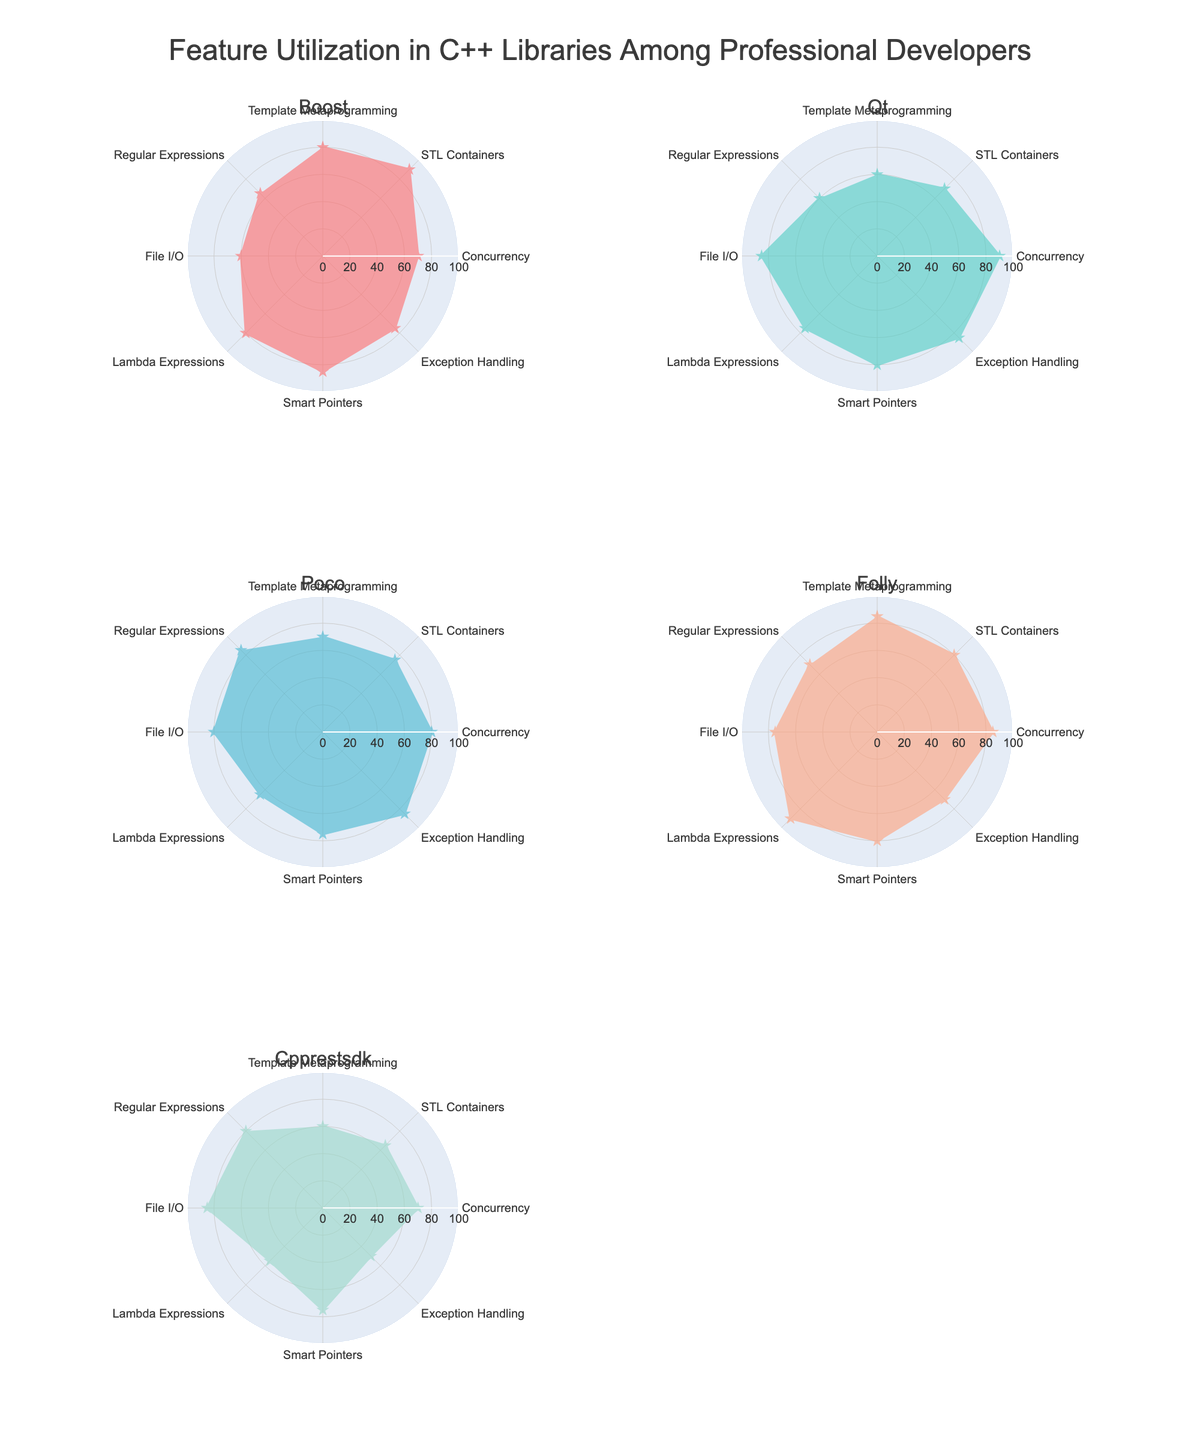Which library has the highest utilization of STL Containers? To find this, look at the corresponding values for STL Containers in each subplot and identify the highest one. Boost has a value of 90 for STL Containers.
Answer: Boost Which feature has the lowest utilization across all libraries? Check the minimum value of each feature across all libraries. Exception Handling in Cpprestsdk has the lowest value of 50.
Answer: Exception Handling Compare the utilization of Smart Pointers between Boost and Folly. Which library has higher utilization? Look at the values for Smart Pointers in both the Boost and Folly subplots. Boost has 85, while Folly has 80.
Answer: Boost What is the average utilization of Lambda Expressions across all libraries? Sum the Lambda Expressions values from all libraries (80 + 75 + 65 + 90 + 55) and divide by the number of libraries (5). (80 + 75 + 65 + 90 + 55) / 5 = 73
Answer: 73 Which library has the most balanced utilization of features, i.e., the least variation across its feature values? Visually assess the uniformity of the values across each radar chart. Qt appears to have the most balanced utilization, with values ranging from 60 to 90.
Answer: Qt Which library has the highest variation in utilization of features? Compare the differences between the highest and lowest values in each subplot. Cpprestsdk has the largest range, from 50 to 85 (35 units).
Answer: Cpprestsdk What is the difference in utilization of File I/O between Qt and Poco? Look at the values for File I/O in Qt (85) and Poco (80). 85 - 80 = 5
Answer: 5 Which feature does every library utilize more than 60%? Identify features where values are greater than 60 in all subplots. STL Containers has values of 90, 70, 75, 80, and 65, all of which are above 60.
Answer: STL Containers What is the total utilization of Concurrency for all libraries? Sum the Concurrency values from each library (70 + 90 + 80 + 85 + 70). 70 + 90 + 80 + 85 + 70 = 395
Answer: 395 